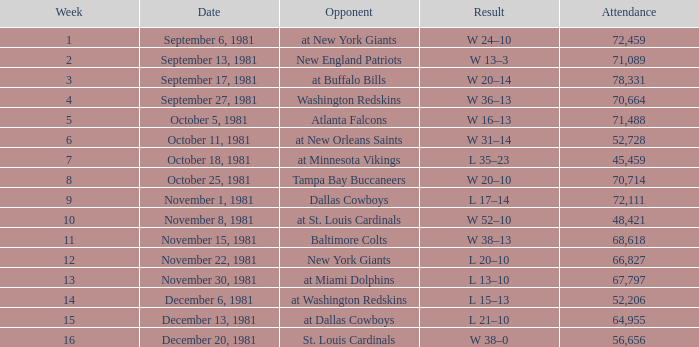What was the usual number of people present on september 17, 1981? 78331.0. 